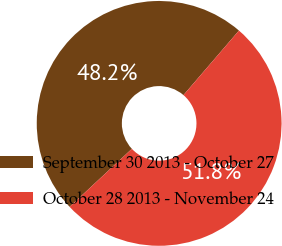<chart> <loc_0><loc_0><loc_500><loc_500><pie_chart><fcel>September 30 2013 - October 27<fcel>October 28 2013 - November 24<nl><fcel>48.24%<fcel>51.76%<nl></chart> 